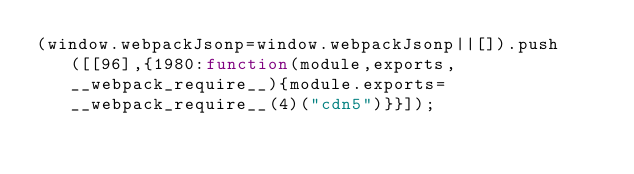Convert code to text. <code><loc_0><loc_0><loc_500><loc_500><_JavaScript_>(window.webpackJsonp=window.webpackJsonp||[]).push([[96],{1980:function(module,exports,__webpack_require__){module.exports=__webpack_require__(4)("cdn5")}}]);</code> 